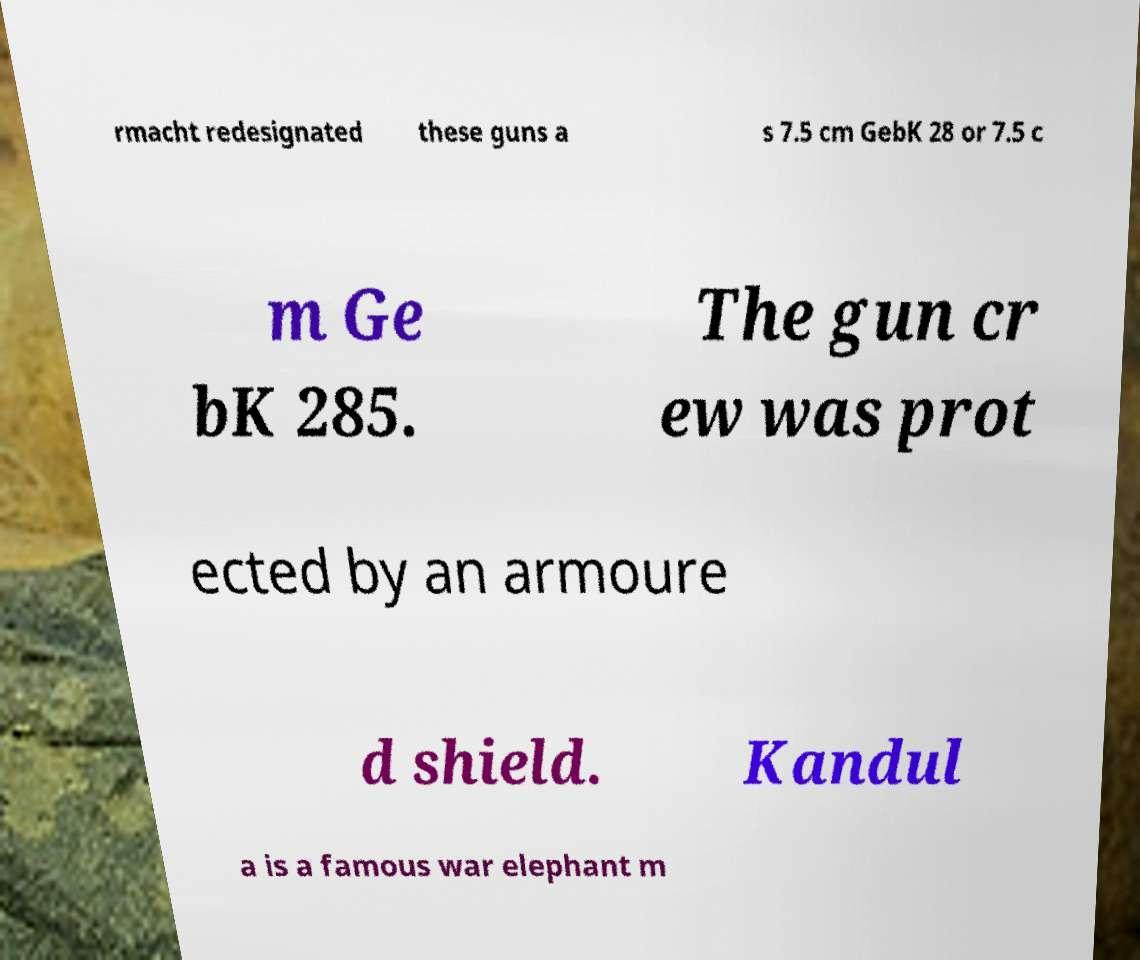There's text embedded in this image that I need extracted. Can you transcribe it verbatim? rmacht redesignated these guns a s 7.5 cm GebK 28 or 7.5 c m Ge bK 285. The gun cr ew was prot ected by an armoure d shield. Kandul a is a famous war elephant m 